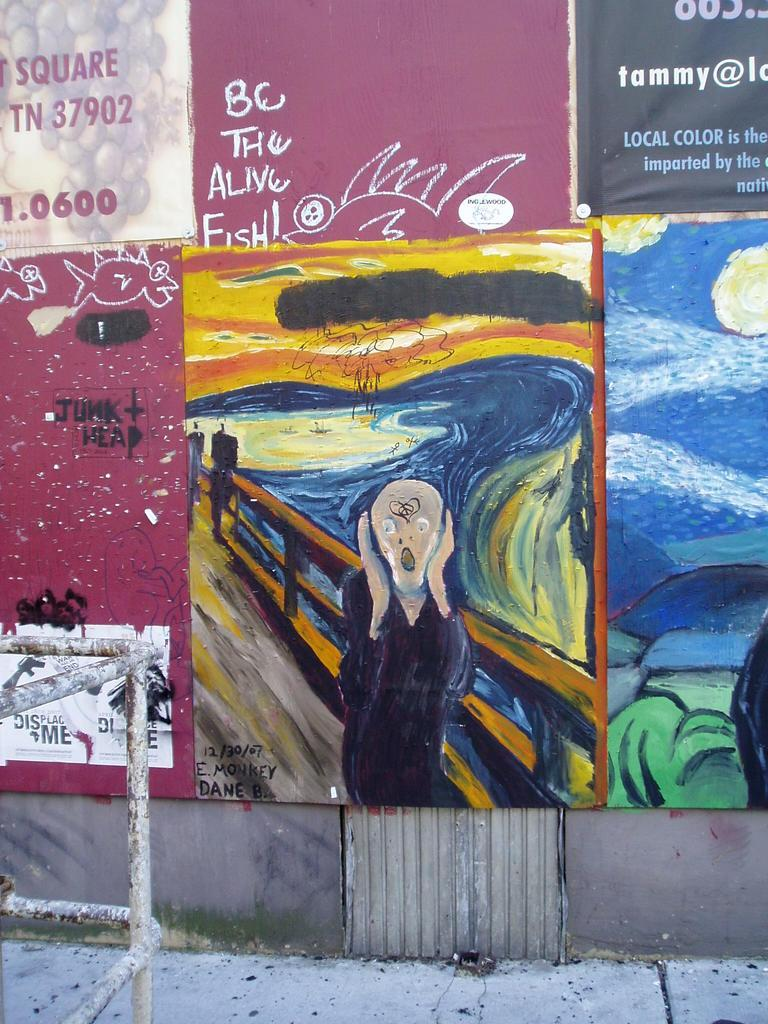<image>
Write a terse but informative summary of the picture. Grafitti is painted on a wall that has BC the alive fish written on it. 